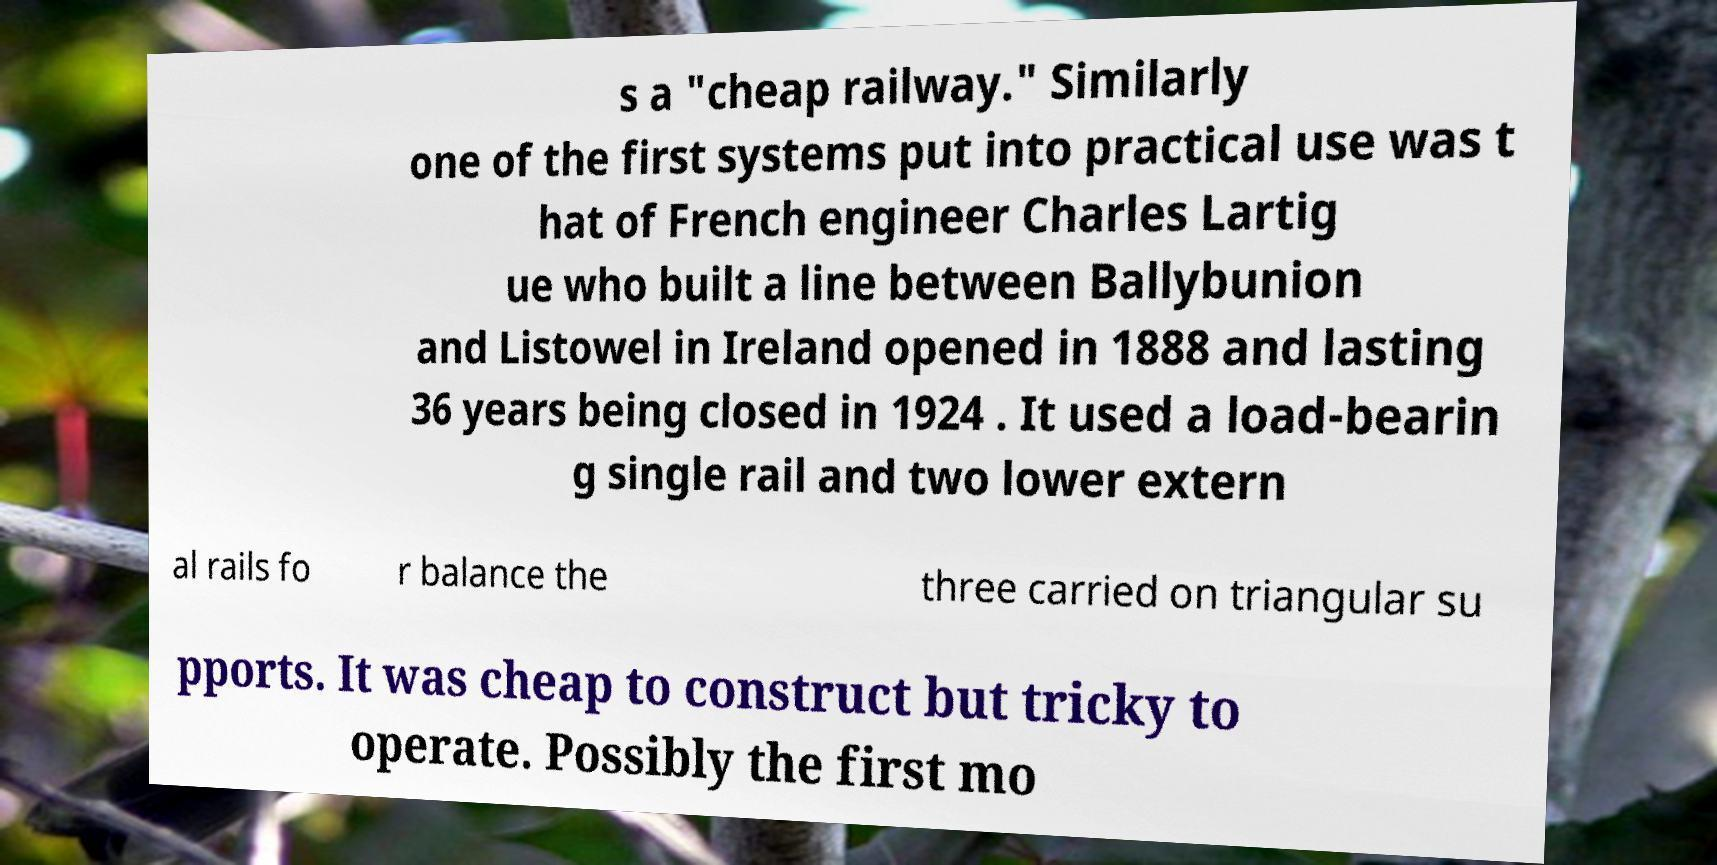What messages or text are displayed in this image? I need them in a readable, typed format. s a "cheap railway." Similarly one of the first systems put into practical use was t hat of French engineer Charles Lartig ue who built a line between Ballybunion and Listowel in Ireland opened in 1888 and lasting 36 years being closed in 1924 . It used a load-bearin g single rail and two lower extern al rails fo r balance the three carried on triangular su pports. It was cheap to construct but tricky to operate. Possibly the first mo 